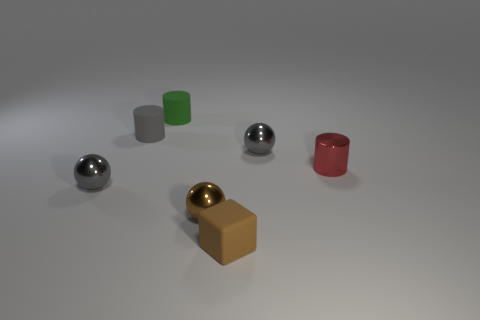There is a small brown matte cube; are there any shiny things behind it?
Ensure brevity in your answer.  Yes. Is the material of the green cylinder the same as the brown cube?
Offer a very short reply. Yes. There is a gray cylinder that is the same size as the red metallic cylinder; what material is it?
Your answer should be compact. Rubber. How many objects are either brown spheres that are to the left of the small brown matte object or gray metallic balls?
Make the answer very short. 3. Are there an equal number of brown things that are on the left side of the small red cylinder and small gray balls?
Provide a succinct answer. Yes. What color is the tiny metallic sphere that is in front of the red object and on the right side of the gray cylinder?
Your response must be concise. Brown. What number of spheres are small green rubber things or small red metal things?
Give a very brief answer. 0. Is the number of brown cubes on the left side of the tiny gray matte thing less than the number of gray objects?
Offer a terse response. Yes. What shape is the green thing that is the same material as the cube?
Keep it short and to the point. Cylinder. What number of metallic spheres are the same color as the matte block?
Your response must be concise. 1. 